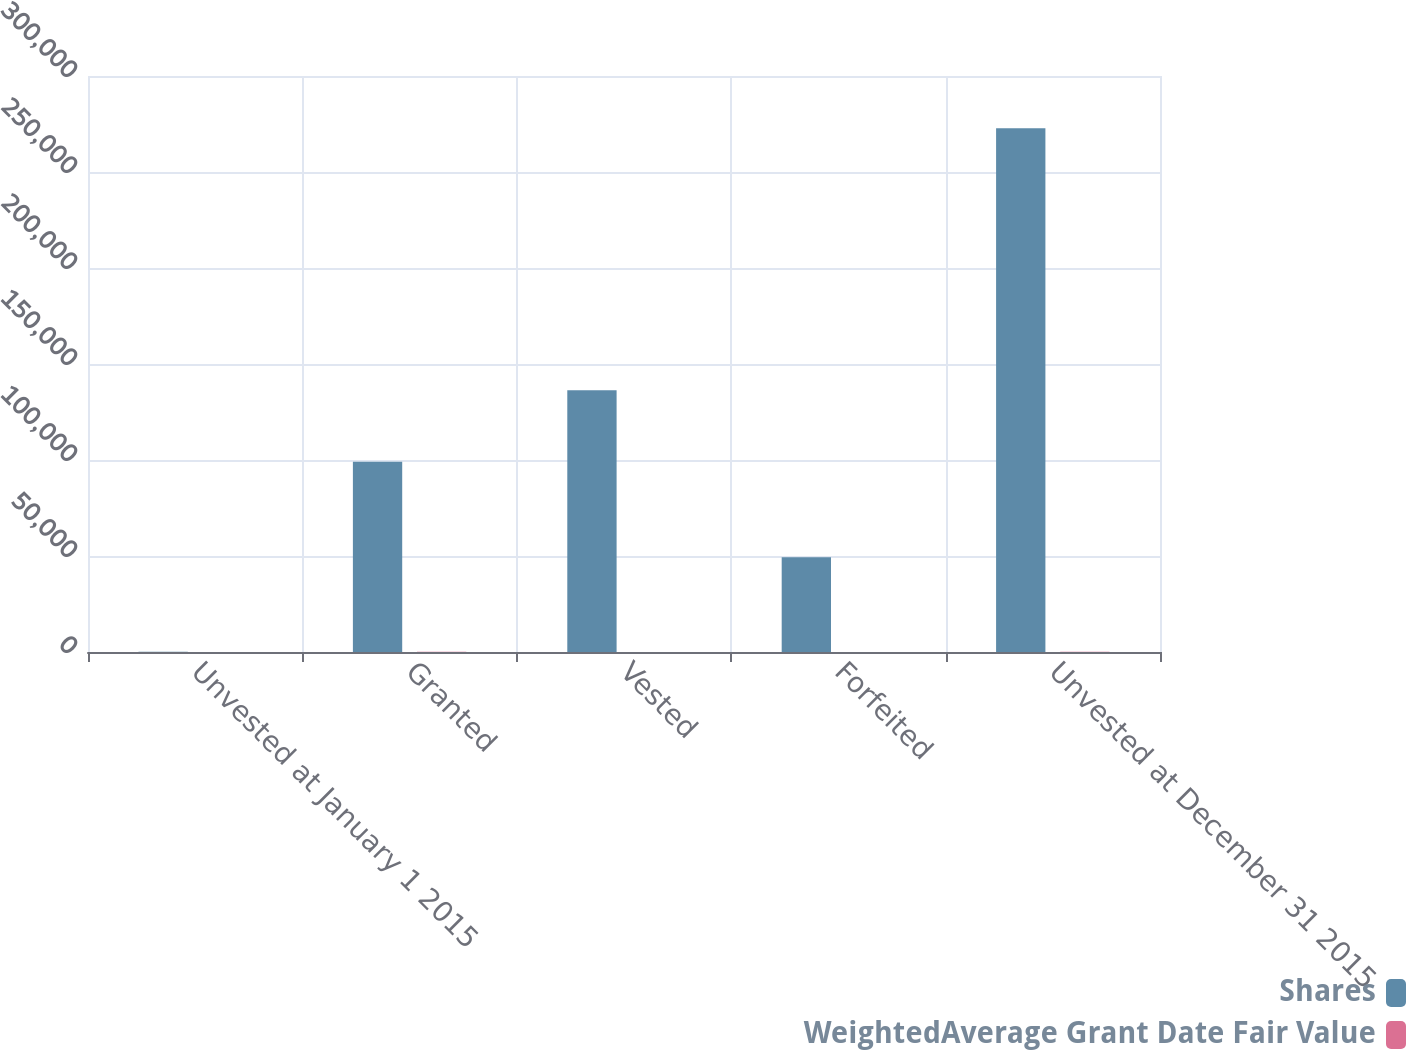Convert chart. <chart><loc_0><loc_0><loc_500><loc_500><stacked_bar_chart><ecel><fcel>Unvested at January 1 2015<fcel>Granted<fcel>Vested<fcel>Forfeited<fcel>Unvested at December 31 2015<nl><fcel>Shares<fcel>78.2<fcel>99130<fcel>136310<fcel>49334<fcel>272755<nl><fcel>WeightedAverage Grant Date Fair Value<fcel>53.68<fcel>78.2<fcel>44.05<fcel>62<fcel>65.9<nl></chart> 